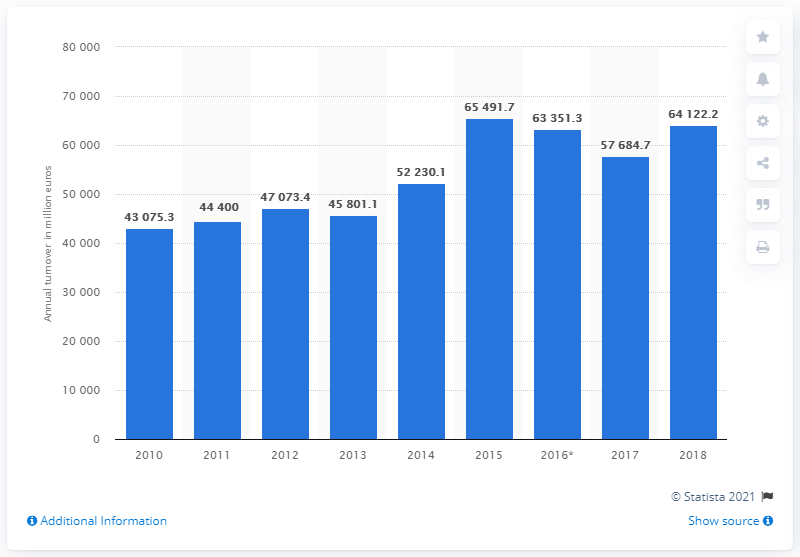Mention a couple of crucial points in this snapshot. The annual revenue of the U.K. civil engineering industry in 2018 was 64,122.2 million pounds. In 2016, the turnover of the civil engineering industry reached 63,351.3 million. 